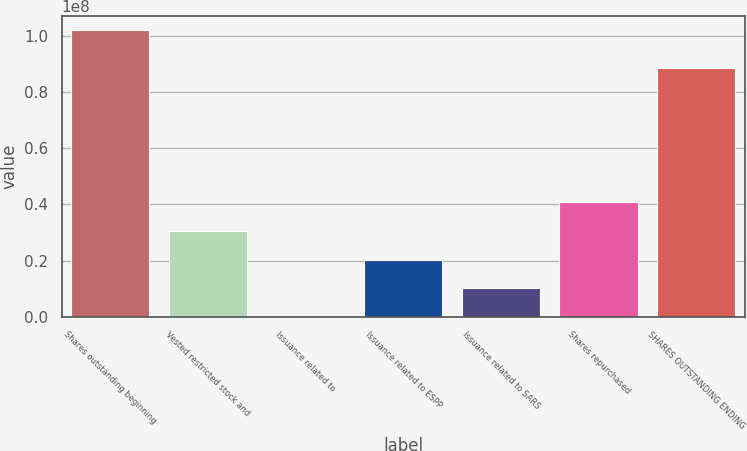Convert chart. <chart><loc_0><loc_0><loc_500><loc_500><bar_chart><fcel>Shares outstanding beginning<fcel>Vested restricted stock and<fcel>Issuance related to<fcel>Issuance related to ESPP<fcel>Issuance related to SARS<fcel>Shares repurchased<fcel>SHARES OUTSTANDING ENDING<nl><fcel>1.02e+08<fcel>3.06001e+07<fcel>3.54<fcel>2.04001e+07<fcel>1.02e+07<fcel>4.08002e+07<fcel>8.85244e+07<nl></chart> 